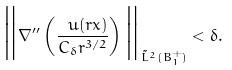<formula> <loc_0><loc_0><loc_500><loc_500>\Big { \| } \nabla ^ { \prime \prime } \left ( \frac { \ u ( r x ) } { C _ { \delta } r ^ { 3 / 2 } } \right ) \Big { \| } _ { \tilde { L } ^ { 2 } ( B _ { 1 } ^ { + } ) } < \delta .</formula> 